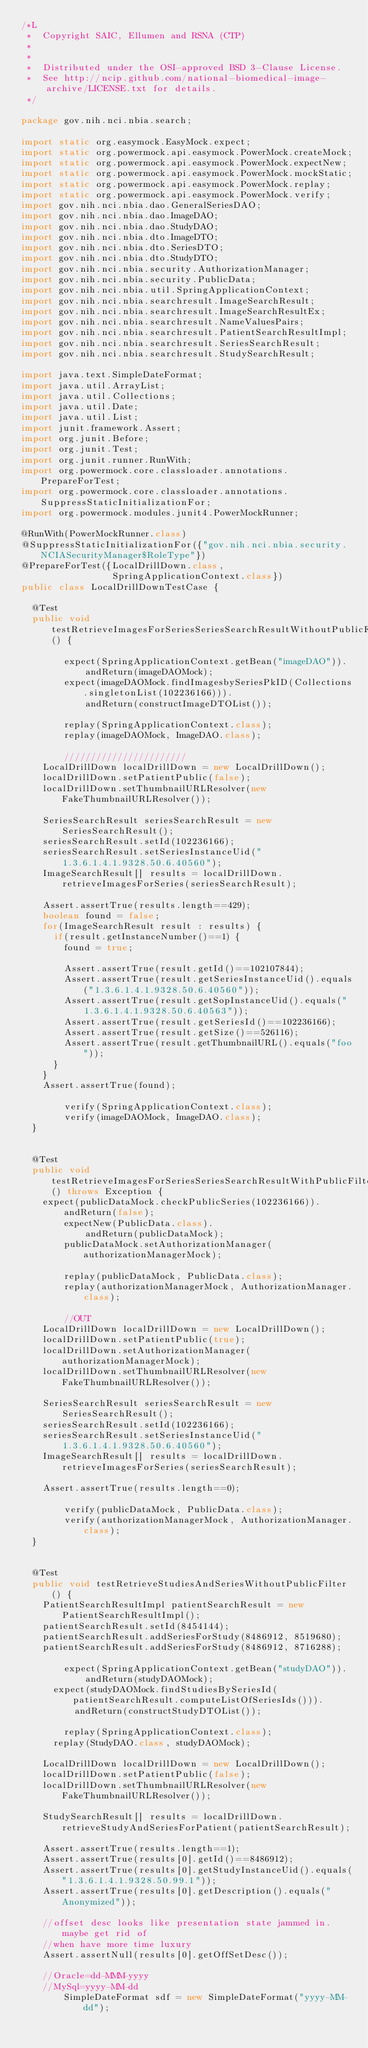<code> <loc_0><loc_0><loc_500><loc_500><_Java_>/*L
 *  Copyright SAIC, Ellumen and RSNA (CTP)
 *
 *
 *  Distributed under the OSI-approved BSD 3-Clause License.
 *  See http://ncip.github.com/national-biomedical-image-archive/LICENSE.txt for details.
 */

package gov.nih.nci.nbia.search;

import static org.easymock.EasyMock.expect;
import static org.powermock.api.easymock.PowerMock.createMock;
import static org.powermock.api.easymock.PowerMock.expectNew;
import static org.powermock.api.easymock.PowerMock.mockStatic;
import static org.powermock.api.easymock.PowerMock.replay;
import static org.powermock.api.easymock.PowerMock.verify;
import gov.nih.nci.nbia.dao.GeneralSeriesDAO;
import gov.nih.nci.nbia.dao.ImageDAO;
import gov.nih.nci.nbia.dao.StudyDAO;
import gov.nih.nci.nbia.dto.ImageDTO;
import gov.nih.nci.nbia.dto.SeriesDTO;
import gov.nih.nci.nbia.dto.StudyDTO;
import gov.nih.nci.nbia.security.AuthorizationManager;
import gov.nih.nci.nbia.security.PublicData;
import gov.nih.nci.nbia.util.SpringApplicationContext;
import gov.nih.nci.nbia.searchresult.ImageSearchResult;
import gov.nih.nci.nbia.searchresult.ImageSearchResultEx;
import gov.nih.nci.nbia.searchresult.NameValuesPairs;
import gov.nih.nci.nbia.searchresult.PatientSearchResultImpl;
import gov.nih.nci.nbia.searchresult.SeriesSearchResult;
import gov.nih.nci.nbia.searchresult.StudySearchResult;

import java.text.SimpleDateFormat;
import java.util.ArrayList;
import java.util.Collections;
import java.util.Date;
import java.util.List;
import junit.framework.Assert;
import org.junit.Before;
import org.junit.Test;
import org.junit.runner.RunWith;
import org.powermock.core.classloader.annotations.PrepareForTest;
import org.powermock.core.classloader.annotations.SuppressStaticInitializationFor;
import org.powermock.modules.junit4.PowerMockRunner;

@RunWith(PowerMockRunner.class)
@SuppressStaticInitializationFor({"gov.nih.nci.nbia.security.NCIASecurityManager$RoleType"})
@PrepareForTest({LocalDrillDown.class,  
                 SpringApplicationContext.class}) 
public class LocalDrillDownTestCase {

	@Test
	public void testRetrieveImagesForSeriesSeriesSearchResultWithoutPublicFilter() {

        expect(SpringApplicationContext.getBean("imageDAO")).
            andReturn(imageDAOMock);
        expect(imageDAOMock.findImagesbySeriesPkID(Collections.singletonList(102236166))).
            andReturn(constructImageDTOList());
    
        replay(SpringApplicationContext.class);
        replay(imageDAOMock, ImageDAO.class);
        
        ///////////////////////
		LocalDrillDown localDrillDown = new LocalDrillDown();
		localDrillDown.setPatientPublic(false);
		localDrillDown.setThumbnailURLResolver(new FakeThumbnailURLResolver());
		
		SeriesSearchResult seriesSearchResult = new SeriesSearchResult();
		seriesSearchResult.setId(102236166);
		seriesSearchResult.setSeriesInstanceUid("1.3.6.1.4.1.9328.50.6.40560");
		ImageSearchResult[] results = localDrillDown.retrieveImagesForSeries(seriesSearchResult);

		Assert.assertTrue(results.length==429);
		boolean found = false;
		for(ImageSearchResult result : results) {
			if(result.getInstanceNumber()==1) {
				found = true;
				
				Assert.assertTrue(result.getId()==102107844);
				Assert.assertTrue(result.getSeriesInstanceUid().equals("1.3.6.1.4.1.9328.50.6.40560"));
				Assert.assertTrue(result.getSopInstanceUid().equals("1.3.6.1.4.1.9328.50.6.40563"));
				Assert.assertTrue(result.getSeriesId()==102236166);
				Assert.assertTrue(result.getSize()==526116);
				Assert.assertTrue(result.getThumbnailURL().equals("foo"));
			}		
		}
		Assert.assertTrue(found);
		
        verify(SpringApplicationContext.class);
        verify(imageDAOMock, ImageDAO.class);		
	}
	

	@Test
	public void testRetrieveImagesForSeriesSeriesSearchResultWithPublicFilter() throws Exception {
		expect(publicDataMock.checkPublicSeries(102236166)).
		    andReturn(false);
        expectNew(PublicData.class).
            andReturn(publicDataMock);        
        publicDataMock.setAuthorizationManager(authorizationManagerMock);
		
        replay(publicDataMock, PublicData.class);
        replay(authorizationManagerMock, AuthorizationManager.class);	
        
        //OUT
		LocalDrillDown localDrillDown = new LocalDrillDown();
		localDrillDown.setPatientPublic(true);
		localDrillDown.setAuthorizationManager(authorizationManagerMock);
		localDrillDown.setThumbnailURLResolver(new FakeThumbnailURLResolver());
		
		SeriesSearchResult seriesSearchResult = new SeriesSearchResult();
		seriesSearchResult.setId(102236166);
		seriesSearchResult.setSeriesInstanceUid("1.3.6.1.4.1.9328.50.6.40560");
		ImageSearchResult[] results = localDrillDown.retrieveImagesForSeries(seriesSearchResult);

		Assert.assertTrue(results.length==0);
		
        verify(publicDataMock, PublicData.class);
        verify(authorizationManagerMock, AuthorizationManager.class);			
	}


	@Test
	public void testRetrieveStudiesAndSeriesWithoutPublicFilter() {
		PatientSearchResultImpl patientSearchResult = new PatientSearchResultImpl();
		patientSearchResult.setId(8454144);		
		patientSearchResult.addSeriesForStudy(8486912, 8519680);
		patientSearchResult.addSeriesForStudy(8486912, 8716288);
						
        expect(SpringApplicationContext.getBean("studyDAO")).
            andReturn(studyDAOMock);
	    expect(studyDAOMock.findStudiesBySeriesId(patientSearchResult.computeListOfSeriesIds())).
	        andReturn(constructStudyDTOList());

        replay(SpringApplicationContext.class);
	    replay(StudyDAO.class, studyDAOMock);
    
		LocalDrillDown localDrillDown = new LocalDrillDown();
		localDrillDown.setPatientPublic(false);
		localDrillDown.setThumbnailURLResolver(new FakeThumbnailURLResolver());

		StudySearchResult[] results = localDrillDown.retrieveStudyAndSeriesForPatient(patientSearchResult);

		Assert.assertTrue(results.length==1);
		Assert.assertTrue(results[0].getId()==8486912);
		Assert.assertTrue(results[0].getStudyInstanceUid().equals("1.3.6.1.4.1.9328.50.99.1"));
		Assert.assertTrue(results[0].getDescription().equals("Anonymized"));
		
		//offset desc looks like presentation state jammed in.  maybe get rid of
		//when have more time luxury
		Assert.assertNull(results[0].getOffSetDesc());
	
		//Oracle=dd-MMM-yyyy
		//MySql=yyyy-MM-dd
        SimpleDateFormat sdf = new SimpleDateFormat("yyyy-MM-dd");</code> 